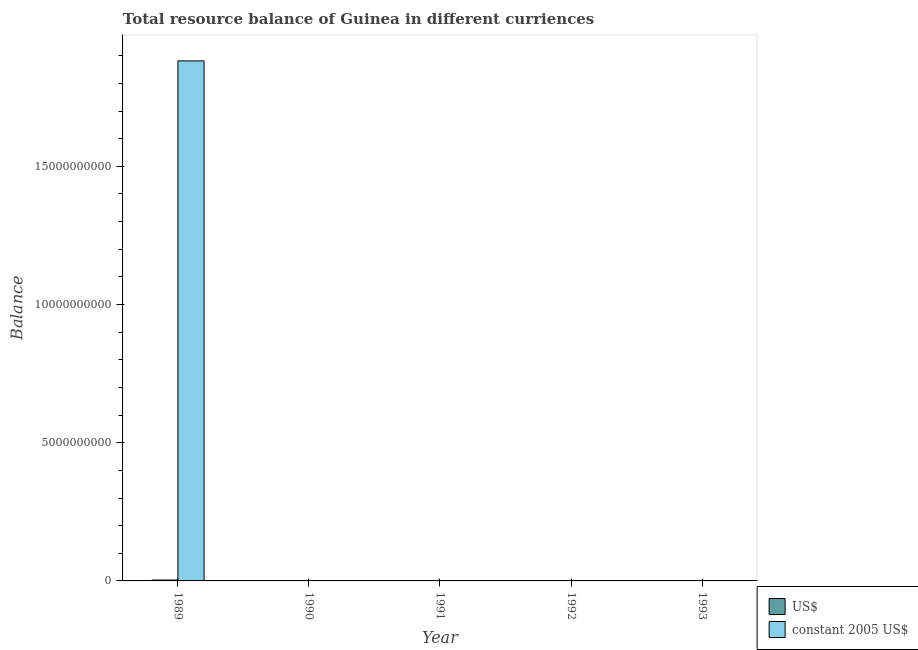What is the label of the 4th group of bars from the left?
Your answer should be very brief. 1992. What is the resource balance in constant us$ in 1991?
Give a very brief answer. 0. Across all years, what is the maximum resource balance in us$?
Give a very brief answer. 3.18e+07. In which year was the resource balance in us$ maximum?
Give a very brief answer. 1989. What is the total resource balance in constant us$ in the graph?
Offer a very short reply. 1.88e+1. What is the average resource balance in constant us$ per year?
Offer a very short reply. 3.76e+09. In the year 1989, what is the difference between the resource balance in constant us$ and resource balance in us$?
Your answer should be compact. 0. What is the difference between the highest and the lowest resource balance in constant us$?
Offer a terse response. 1.88e+1. How many years are there in the graph?
Ensure brevity in your answer.  5. What is the difference between two consecutive major ticks on the Y-axis?
Your answer should be very brief. 5.00e+09. Are the values on the major ticks of Y-axis written in scientific E-notation?
Your answer should be very brief. No. Does the graph contain any zero values?
Your response must be concise. Yes. How many legend labels are there?
Ensure brevity in your answer.  2. What is the title of the graph?
Your response must be concise. Total resource balance of Guinea in different curriences. Does "Age 15+" appear as one of the legend labels in the graph?
Your response must be concise. No. What is the label or title of the X-axis?
Provide a short and direct response. Year. What is the label or title of the Y-axis?
Ensure brevity in your answer.  Balance. What is the Balance in US$ in 1989?
Provide a short and direct response. 3.18e+07. What is the Balance in constant 2005 US$ in 1989?
Ensure brevity in your answer.  1.88e+1. What is the Balance in constant 2005 US$ in 1990?
Your answer should be compact. 0. What is the Balance in US$ in 1991?
Provide a succinct answer. 0. What is the Balance of constant 2005 US$ in 1993?
Ensure brevity in your answer.  0. Across all years, what is the maximum Balance in US$?
Your answer should be very brief. 3.18e+07. Across all years, what is the maximum Balance in constant 2005 US$?
Offer a terse response. 1.88e+1. What is the total Balance of US$ in the graph?
Your answer should be very brief. 3.18e+07. What is the total Balance of constant 2005 US$ in the graph?
Your answer should be compact. 1.88e+1. What is the average Balance of US$ per year?
Your response must be concise. 6.36e+06. What is the average Balance in constant 2005 US$ per year?
Your answer should be compact. 3.76e+09. In the year 1989, what is the difference between the Balance of US$ and Balance of constant 2005 US$?
Provide a succinct answer. -1.88e+1. What is the difference between the highest and the lowest Balance of US$?
Give a very brief answer. 3.18e+07. What is the difference between the highest and the lowest Balance of constant 2005 US$?
Your answer should be very brief. 1.88e+1. 